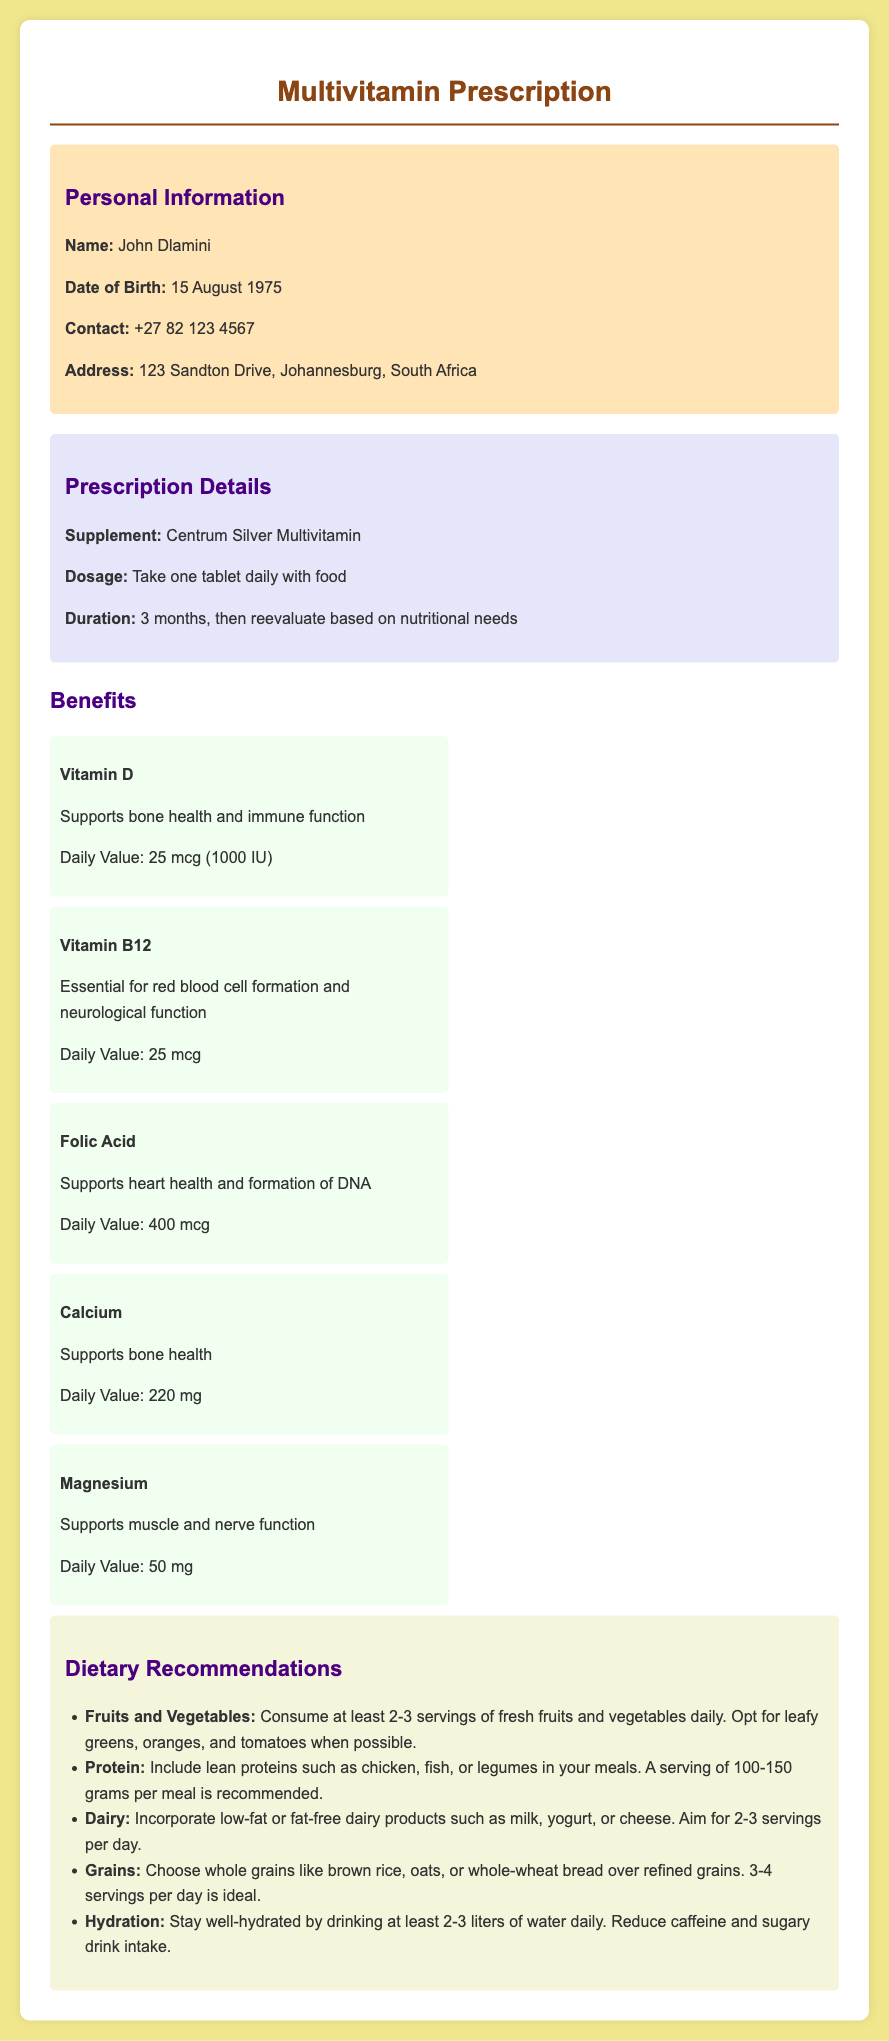What is the name of the supplement? The name of the supplement is explicitly stated in the prescription details section of the document.
Answer: Centrum Silver Multivitamin What is the dosage recommendation? The document specifies the dosage recommendation under the prescription details section.
Answer: Take one tablet daily with food How long should the supplement be taken? The duration for taking the supplement is outlined in the prescription details section of the document.
Answer: 3 months What is the Daily Value of Vitamin D? The Daily Value for Vitamin D is provided under the benefits section, specifically for this vitamin.
Answer: 25 mcg (1000 IU) Which vitamin is essential for red blood cell formation? The document lists the benefits of different vitamins including the one essential for red blood cell formation in the benefits section.
Answer: Vitamin B12 What type of dietary recommendations are given regarding fruits and vegetables? The dietary recommendations section includes specific advice about fruits and vegetables intake.
Answer: Consume at least 2-3 servings of fresh fruits and vegetables daily What is the recommended daily water intake? The document clearly states the recommended daily water intake in the dietary recommendations section.
Answer: 2-3 liters How many servings of dairy are recommended daily? The document specifies the recommended servings of dairy products in the dietary recommendations section.
Answer: 2-3 servings What is the primary purpose of taking a multivitamin supplement according to this prescription? The overall benefits of multivitamins are highlighted, focusing on areas such as bone health and immune function.
Answer: Supports overall health 